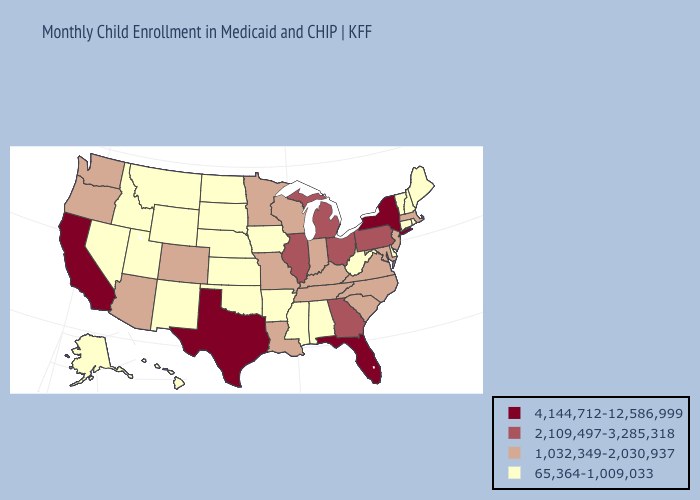Does California have the highest value in the West?
Concise answer only. Yes. Does Kentucky have a lower value than New Jersey?
Keep it brief. No. Which states have the highest value in the USA?
Keep it brief. California, Florida, New York, Texas. Does the first symbol in the legend represent the smallest category?
Short answer required. No. Does Texas have a lower value than Montana?
Quick response, please. No. Does the map have missing data?
Give a very brief answer. No. What is the value of Ohio?
Give a very brief answer. 2,109,497-3,285,318. Does Idaho have the lowest value in the West?
Concise answer only. Yes. Is the legend a continuous bar?
Be succinct. No. What is the lowest value in the USA?
Short answer required. 65,364-1,009,033. What is the value of Oklahoma?
Give a very brief answer. 65,364-1,009,033. What is the value of Rhode Island?
Keep it brief. 65,364-1,009,033. Name the states that have a value in the range 65,364-1,009,033?
Be succinct. Alabama, Alaska, Arkansas, Connecticut, Delaware, Hawaii, Idaho, Iowa, Kansas, Maine, Mississippi, Montana, Nebraska, Nevada, New Hampshire, New Mexico, North Dakota, Oklahoma, Rhode Island, South Dakota, Utah, Vermont, West Virginia, Wyoming. Does the map have missing data?
Quick response, please. No. What is the value of South Carolina?
Be succinct. 1,032,349-2,030,937. 